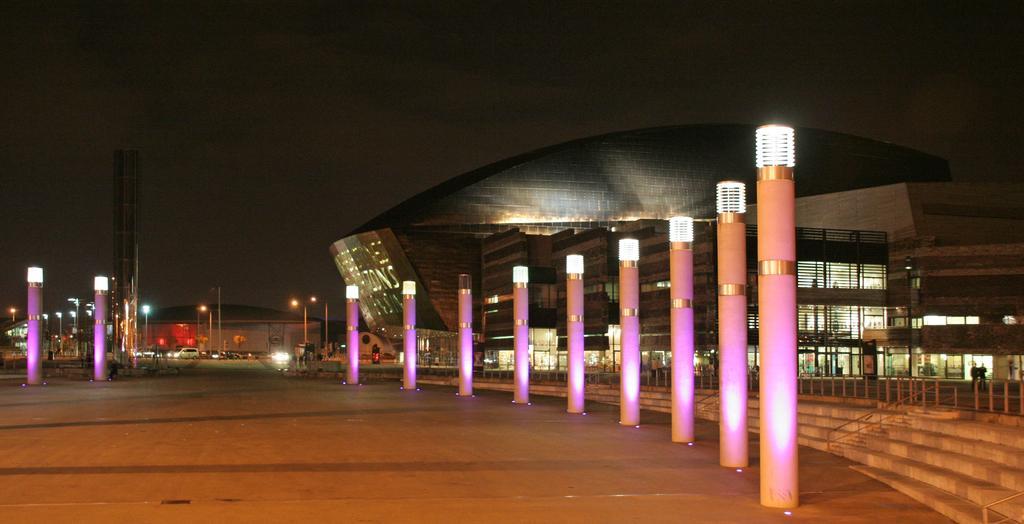Please provide a concise description of this image. In this image in the center there are some poles, and in the background there are buildings, towers, lights and some vehicles. At the bottom there is road, and on the right side there are some stairs and railing and on the left side of the image there is tower. At the top there is sky. 